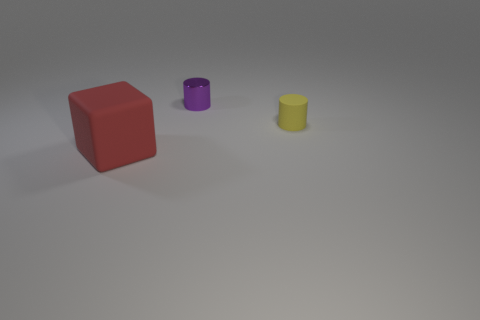Is there anything else that has the same material as the tiny purple thing?
Your answer should be very brief. No. What is the color of the cylinder that is the same size as the yellow matte thing?
Make the answer very short. Purple. Are there any metallic things of the same shape as the tiny rubber thing?
Provide a short and direct response. Yes. What size is the object that is in front of the metallic cylinder and to the left of the tiny matte cylinder?
Offer a very short reply. Large. What color is the other small object that is the same shape as the small purple shiny thing?
Ensure brevity in your answer.  Yellow. Does the thing that is right of the purple object have the same material as the small thing that is on the left side of the small matte object?
Give a very brief answer. No. What shape is the thing that is both to the left of the small yellow cylinder and in front of the tiny purple metallic thing?
Your response must be concise. Cube. The other object that is the same shape as the tiny yellow rubber thing is what size?
Make the answer very short. Small. What color is the cylinder behind the small matte cylinder?
Make the answer very short. Purple. How many other things are there of the same size as the red rubber block?
Provide a short and direct response. 0. 